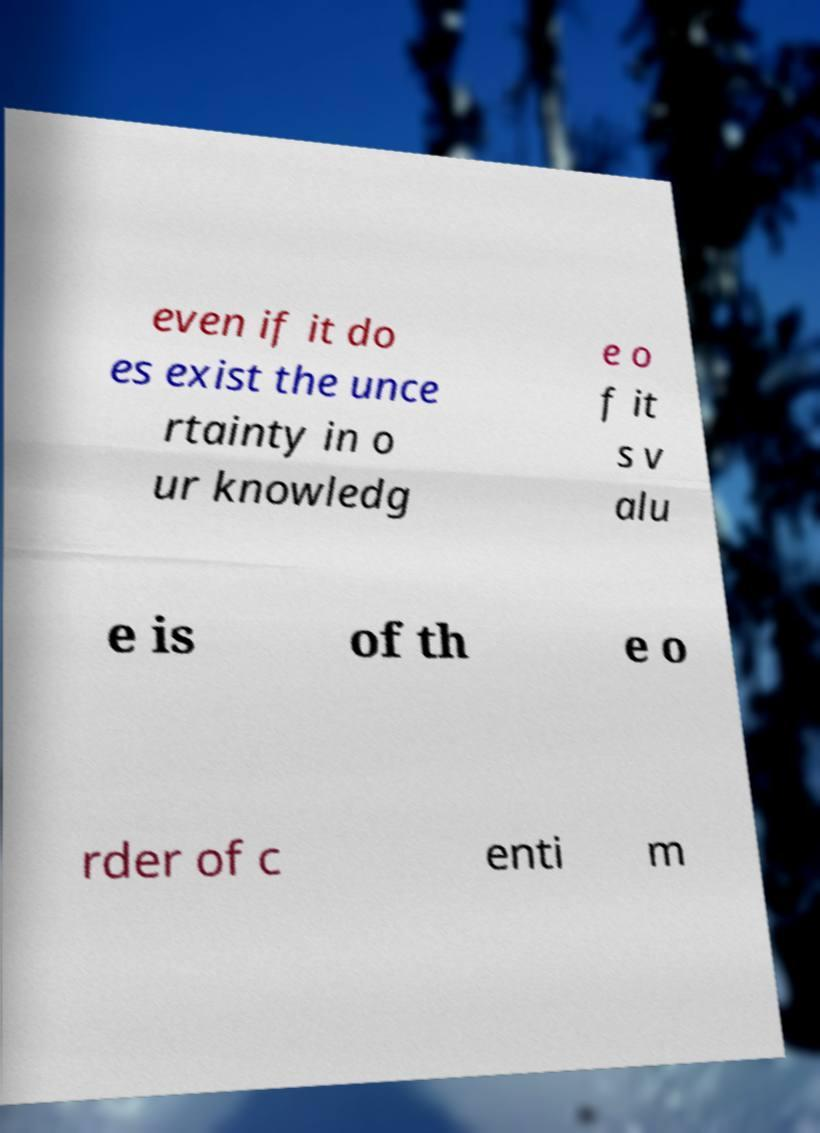Could you assist in decoding the text presented in this image and type it out clearly? even if it do es exist the unce rtainty in o ur knowledg e o f it s v alu e is of th e o rder of c enti m 